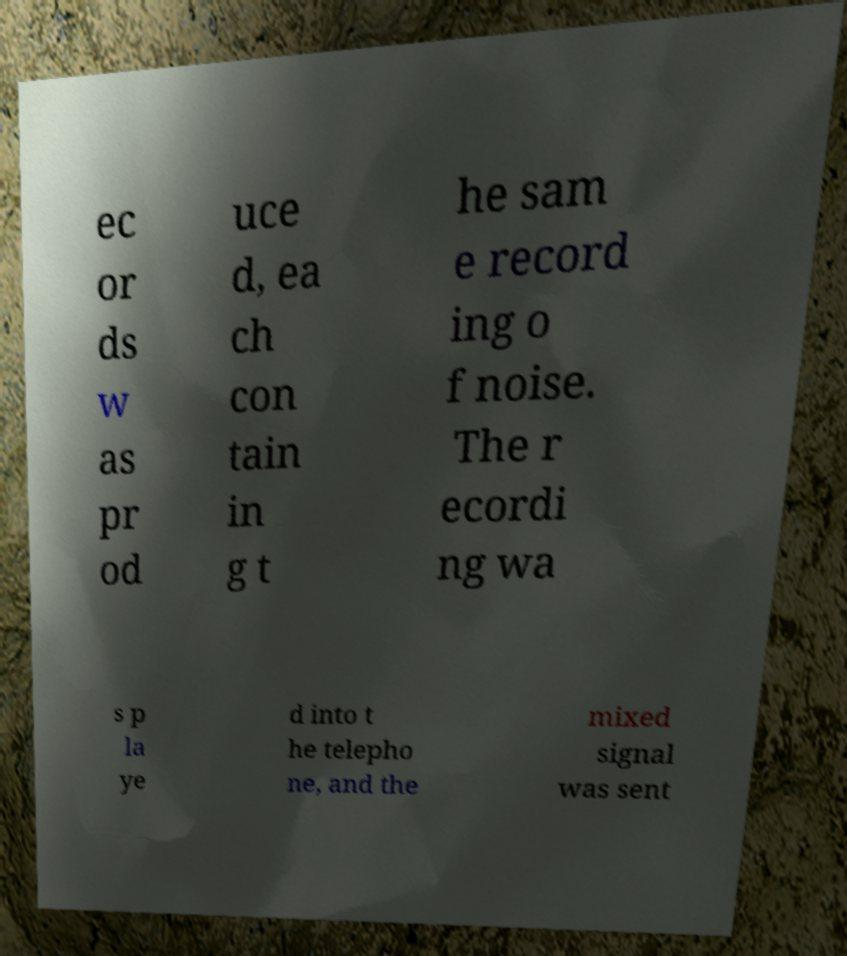Could you assist in decoding the text presented in this image and type it out clearly? ec or ds w as pr od uce d, ea ch con tain in g t he sam e record ing o f noise. The r ecordi ng wa s p la ye d into t he telepho ne, and the mixed signal was sent 